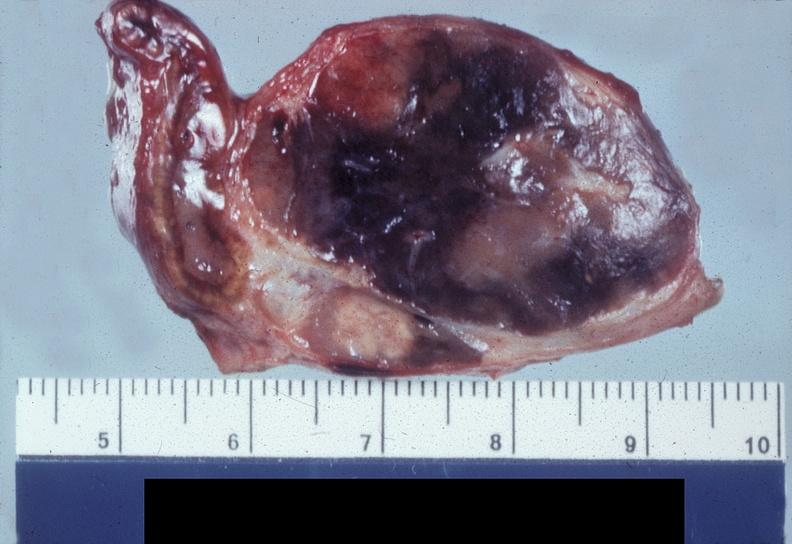s granulomata slide present?
Answer the question using a single word or phrase. No 